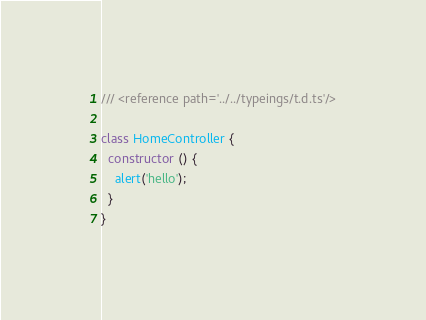Convert code to text. <code><loc_0><loc_0><loc_500><loc_500><_TypeScript_>/// <reference path='../../typeings/t.d.ts'/>

class HomeController {
  constructor () {
    alert('hello');
  }
}
</code> 